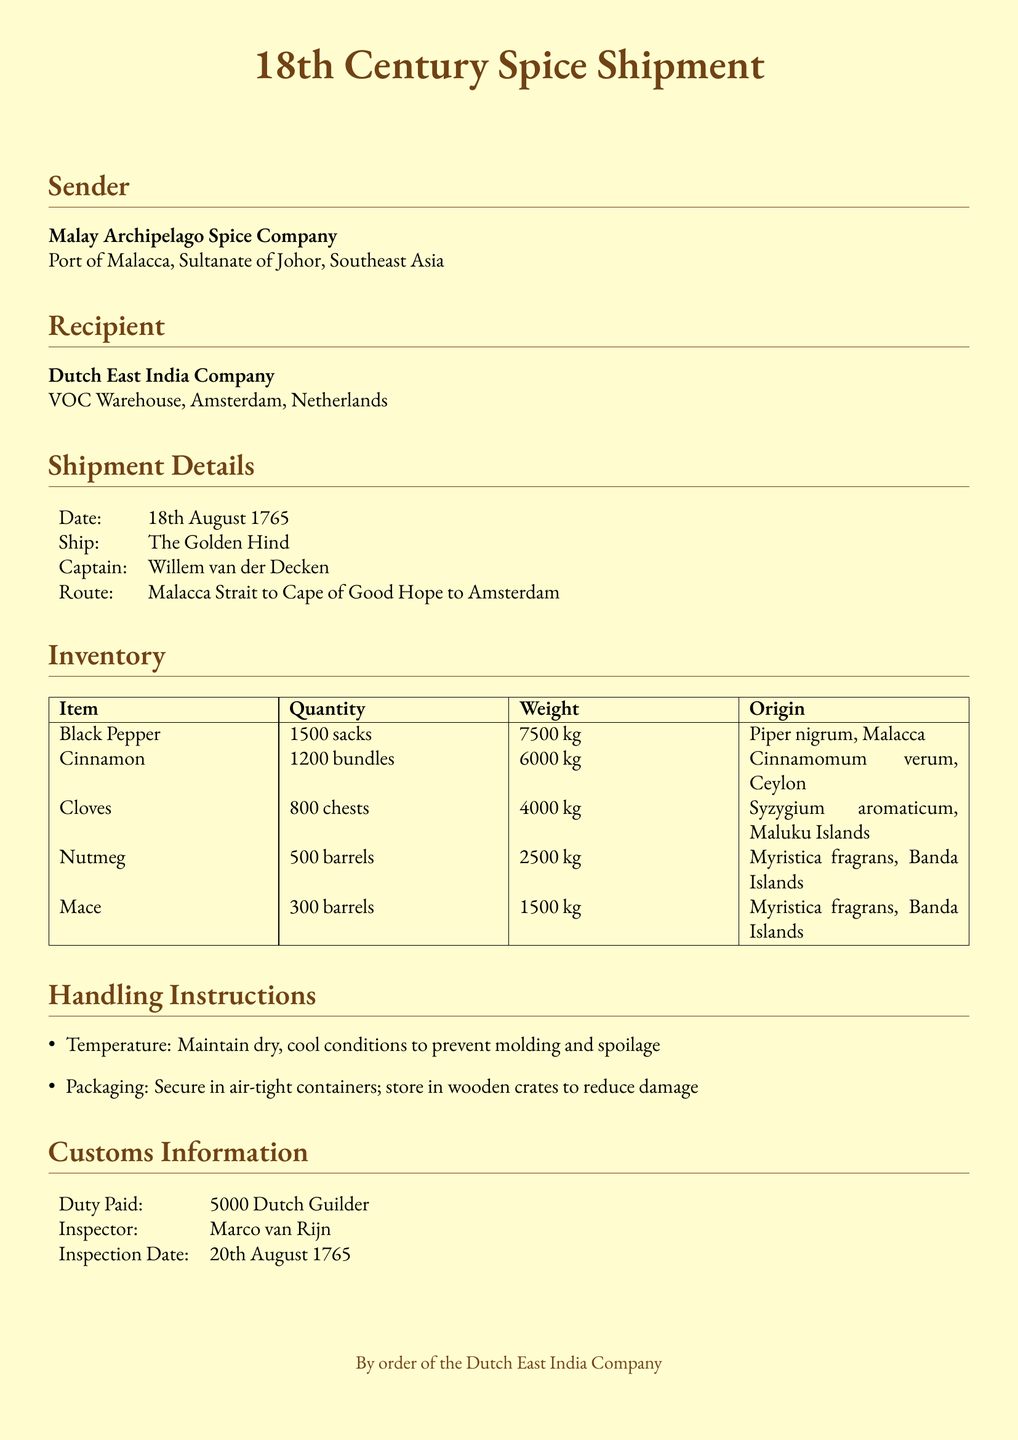What is the sender's name? The sender is identified as the Malay Archipelago Spice Company in the document.
Answer: Malay Archipelago Spice Company What is the date of shipment? The shipment date is specified in the shipment details section.
Answer: 18th August 1765 Who is the captain of the ship? The captain's name is mentioned in the shipment details, indicating who is in charge of the ship.
Answer: Willem van der Decken How many chests of cloves were shipped? The inventory section lists the quantity of cloves in chests.
Answer: 800 chests What is the weight of the cinnamon shipped? The weight of cinnamon is included in the inventory details.
Answer: 6000 kg What route did the shipment take? The document details the specific route traveled from Malacca to Amsterdam.
Answer: Malacca Strait to Cape of Good Hope to Amsterdam What is the duty paid for customs? The customs information section states the amount that was paid in duties for the shipment.
Answer: 5000 Dutch Guilder What type of containers were spices stored in? The handling instructions describe the type of containers recommended for storing the spices.
Answer: air-tight containers Who inspected the shipment? The customs information section provides the name of the inspector who oversaw the shipment.
Answer: Marco van Rijn 